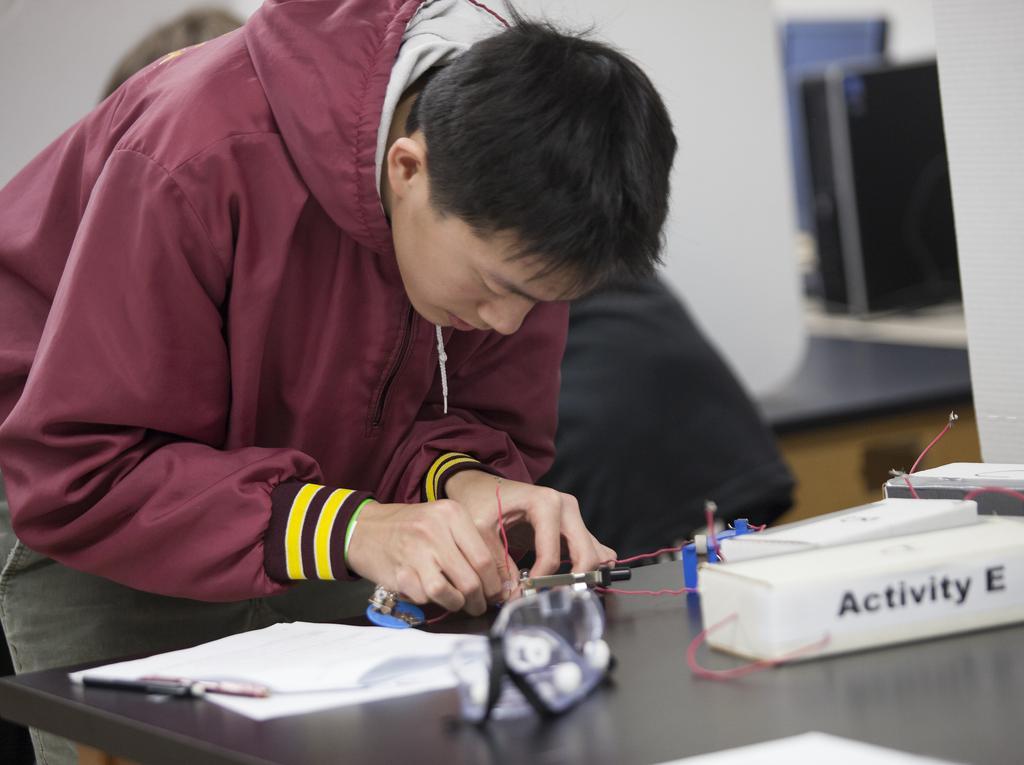In one or two sentences, can you explain what this image depicts? In this picture I can see a man holding the wires with his hand, on the left side there are pens and papers on the table. On the right side I can see a desktop and a CPU. 